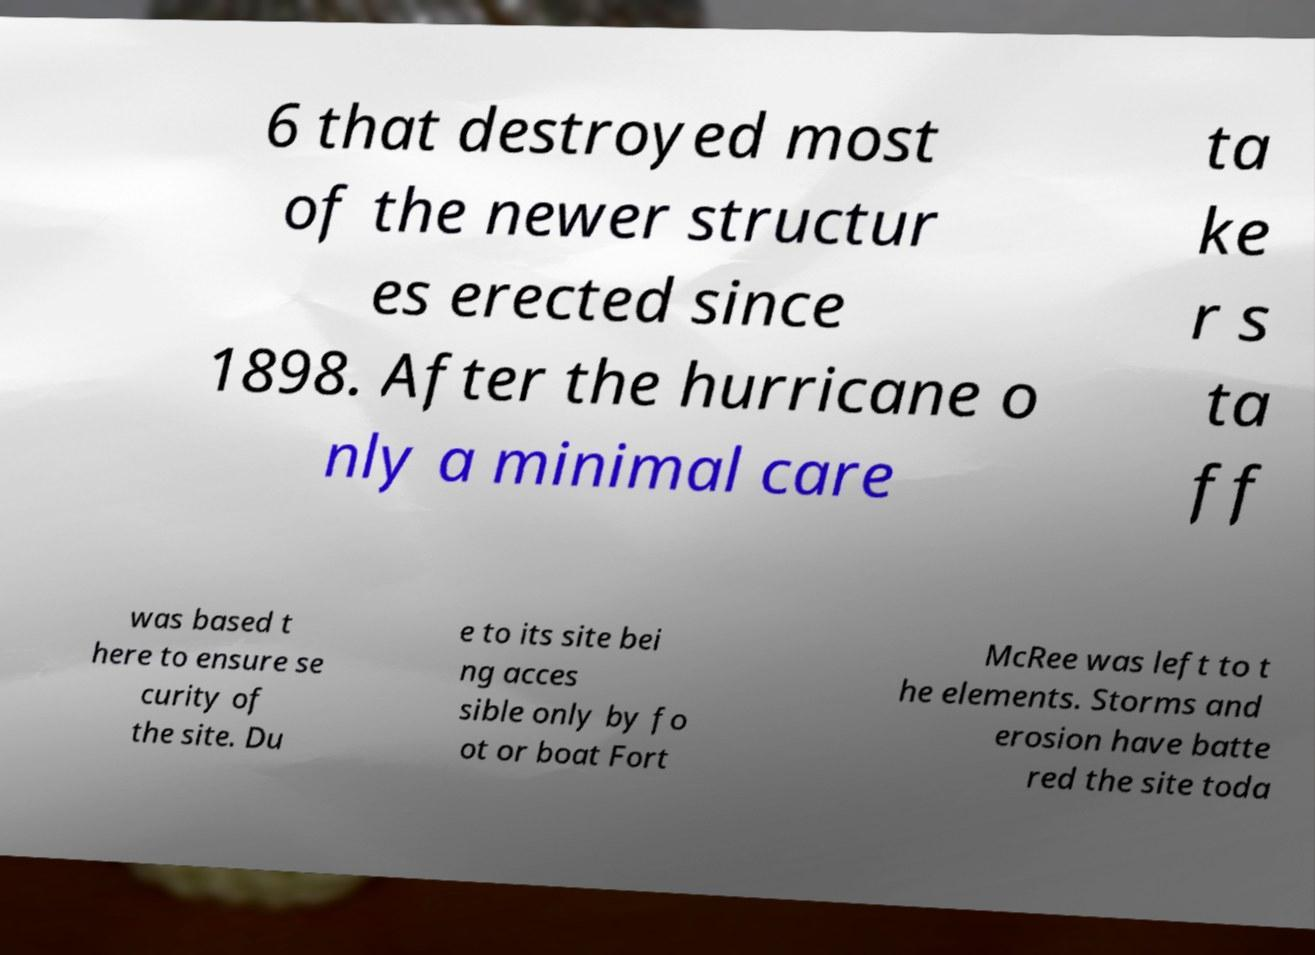For documentation purposes, I need the text within this image transcribed. Could you provide that? 6 that destroyed most of the newer structur es erected since 1898. After the hurricane o nly a minimal care ta ke r s ta ff was based t here to ensure se curity of the site. Du e to its site bei ng acces sible only by fo ot or boat Fort McRee was left to t he elements. Storms and erosion have batte red the site toda 